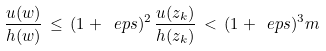Convert formula to latex. <formula><loc_0><loc_0><loc_500><loc_500>\frac { u ( w ) } { h ( w ) } \, \leq \, ( 1 + \ e p s ) ^ { 2 } \, \frac { u ( z _ { k } ) } { h ( z _ { k } ) } \, < \, ( 1 + \ e p s ) ^ { 3 } m</formula> 